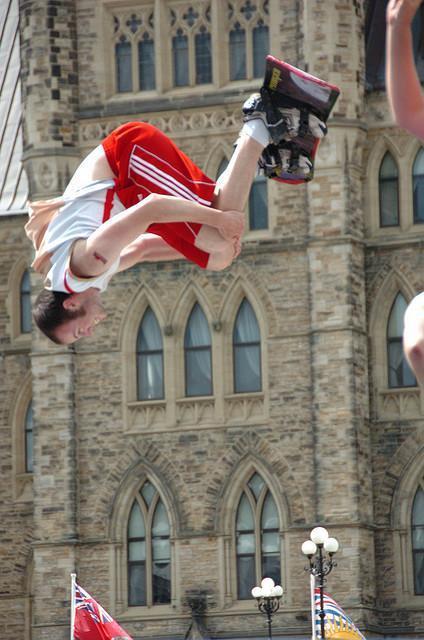How many people are in the photo?
Give a very brief answer. 2. How many bears are there?
Give a very brief answer. 0. 